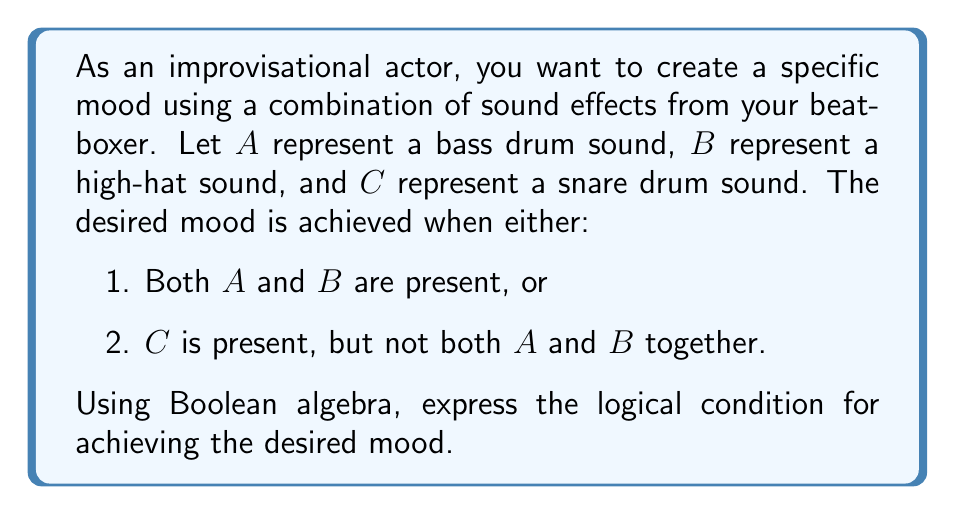Teach me how to tackle this problem. Let's approach this step-by-step:

1. First, let's define our variables:
   A: Bass drum sound
   B: High-hat sound
   C: Snare drum sound

2. Now, let's break down the conditions:
   Condition 1: Both A and B are present
   This can be expressed as: $A \wedge B$

   Condition 2: C is present, but not both A and B together
   This can be expressed as: $C \wedge \neg(A \wedge B)$

3. We want either of these conditions to be true, so we use the OR operator ($\vee$):
   $(A \wedge B) \vee (C \wedge \neg(A \wedge B))$

4. This expression can be simplified using Boolean algebra laws:
   $(A \wedge B) \vee (C \wedge (\neg A \vee \neg B))$ (De Morgan's Law)

5. Expanding this using the distributive property:
   $(A \wedge B) \vee (C \wedge \neg A) \vee (C \wedge \neg B)$

This final expression represents the logical condition for achieving the desired mood using the given sound effects.
Answer: $(A \wedge B) \vee (C \wedge \neg A) \vee (C \wedge \neg B)$ 